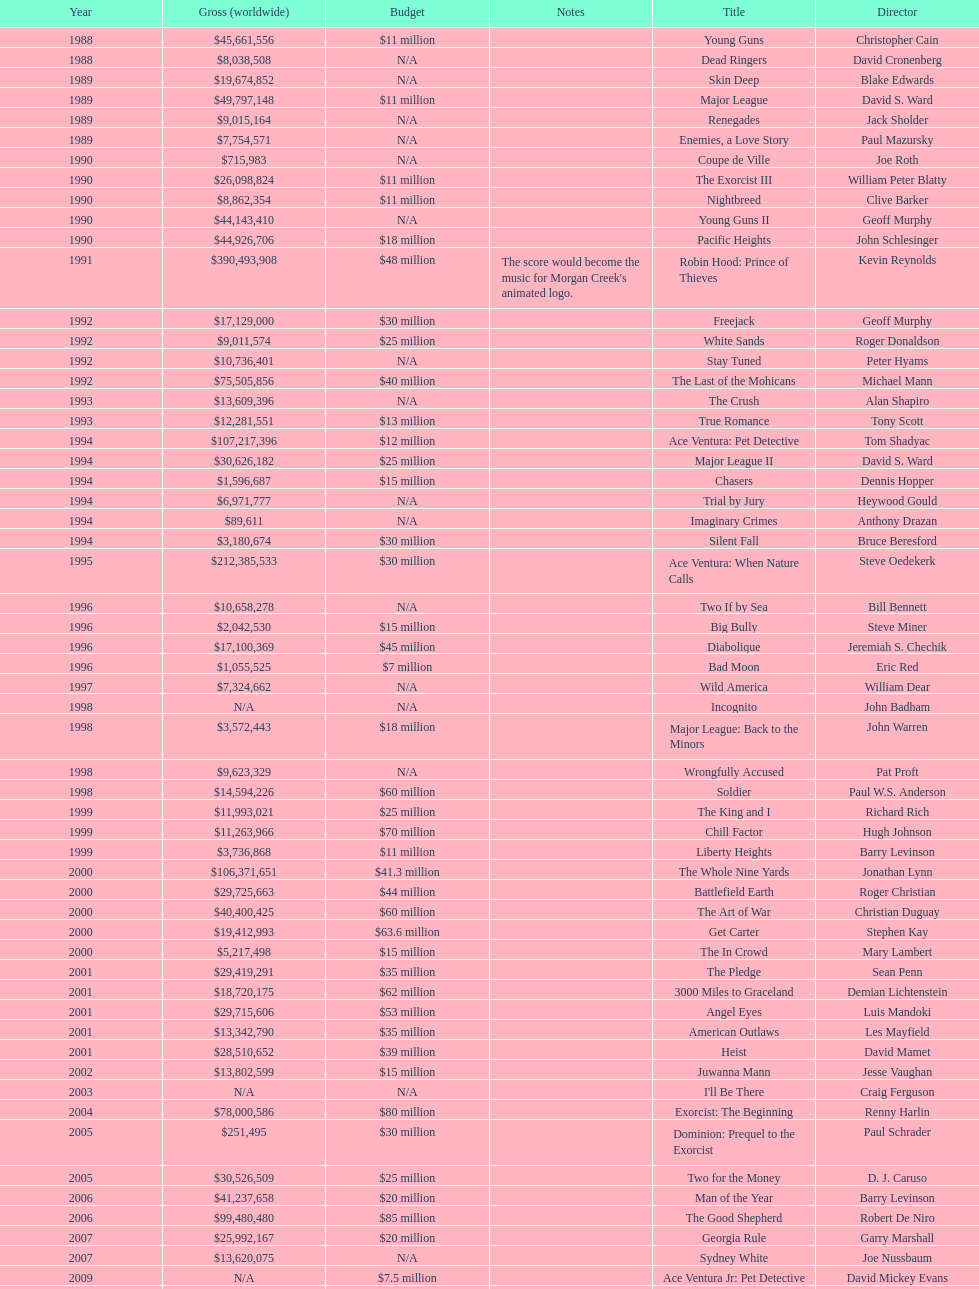Which morgan creek film grossed the most money prior to 1994? Robin Hood: Prince of Thieves. 